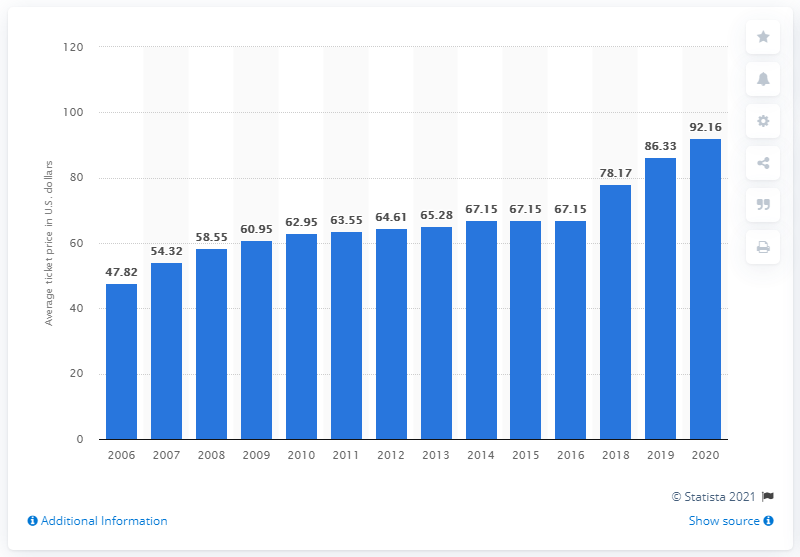Specify some key components in this picture. The average ticket price for Tennessee Titans games in 2020 was $92.16. 